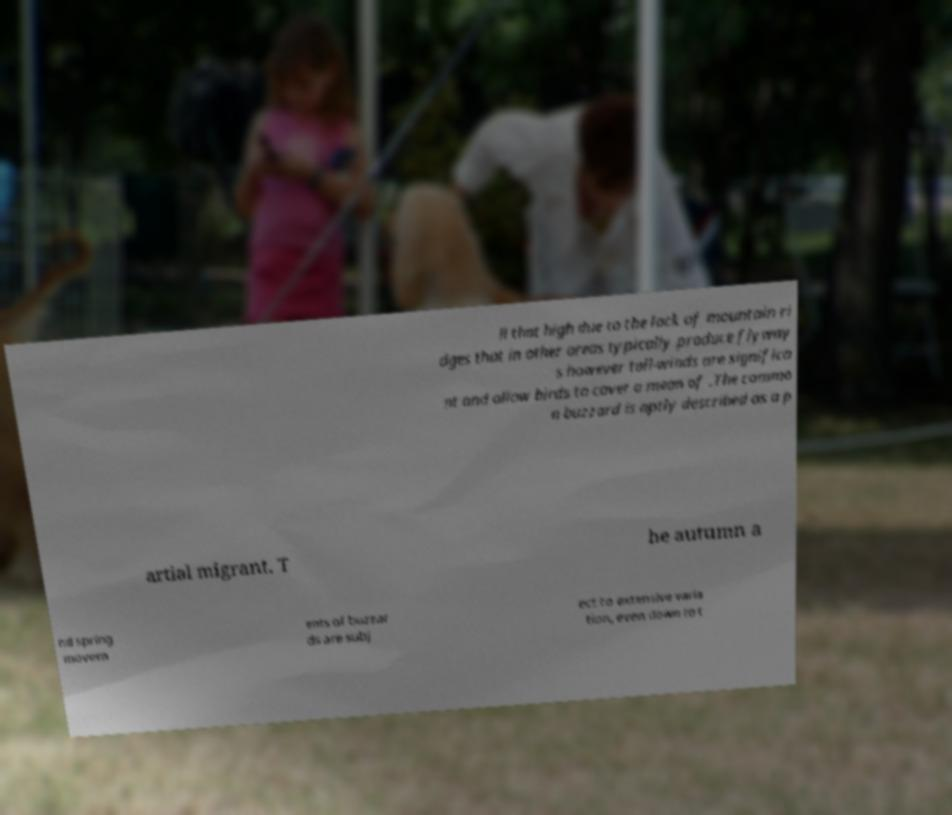Please read and relay the text visible in this image. What does it say? ll that high due to the lack of mountain ri dges that in other areas typically produce flyway s however tail-winds are significa nt and allow birds to cover a mean of .The commo n buzzard is aptly described as a p artial migrant. T he autumn a nd spring movem ents of buzzar ds are subj ect to extensive varia tion, even down to t 